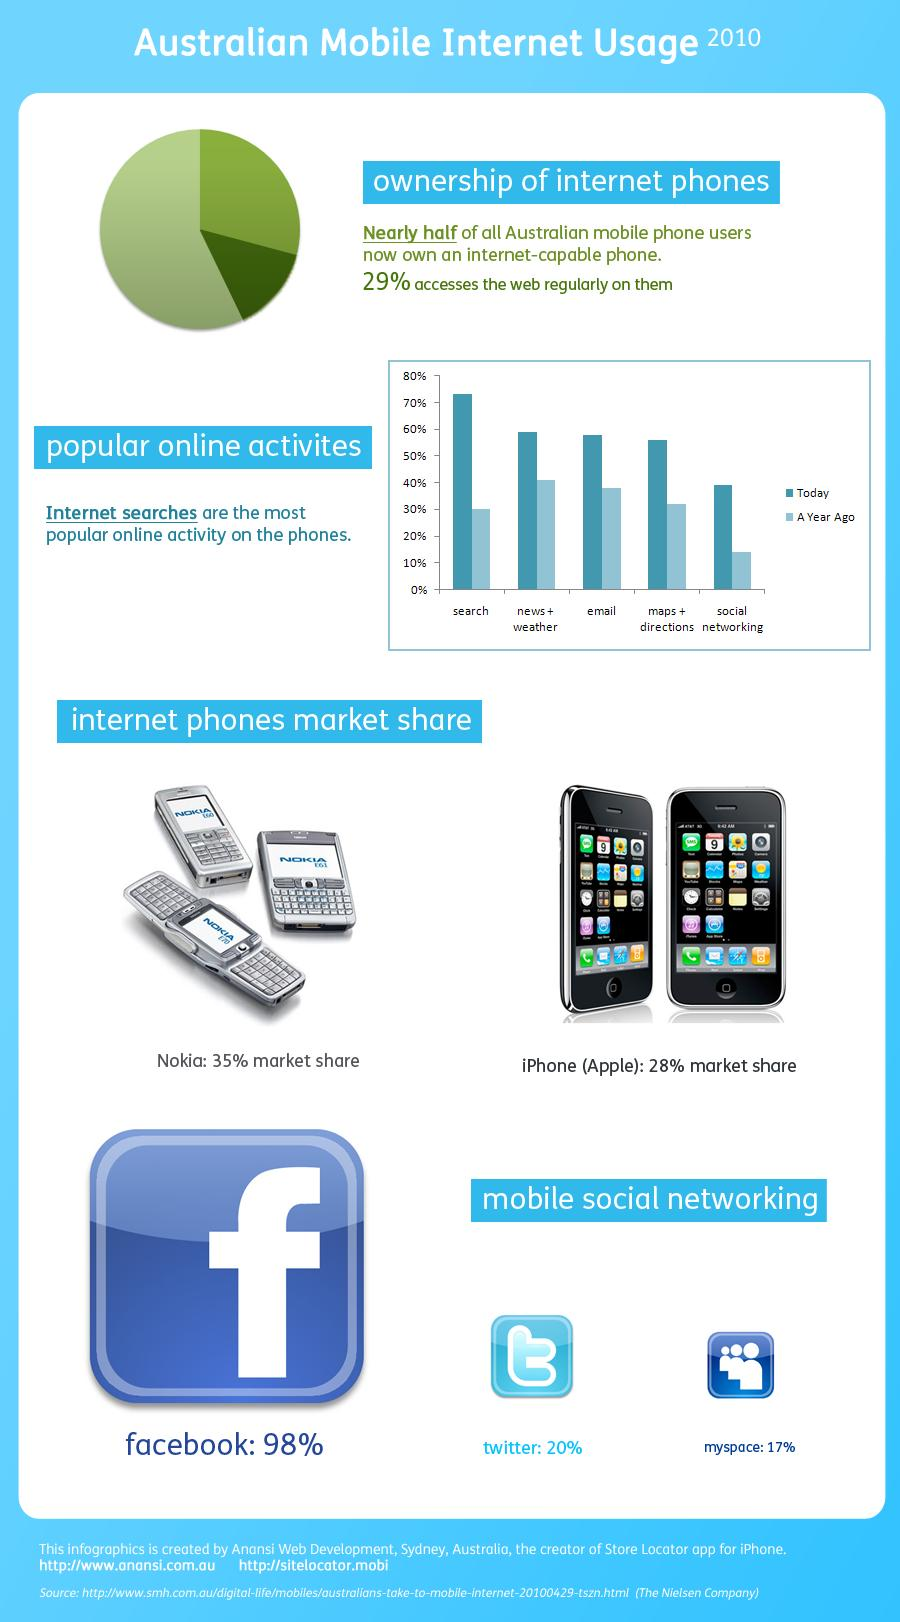Indicate a few pertinent items in this graphic. In the year 2010, in Australia, Facebook was the mobile social networking site that contributed to the highest market share. In the year 2010, Nokia was the brand of mobile phone with the highest market share in Australia. In the year 2010, social networking was the least popular online activity on phones. In the year 2010, MySpace was the mobile social networking site that had the lowest market share in Australia. 